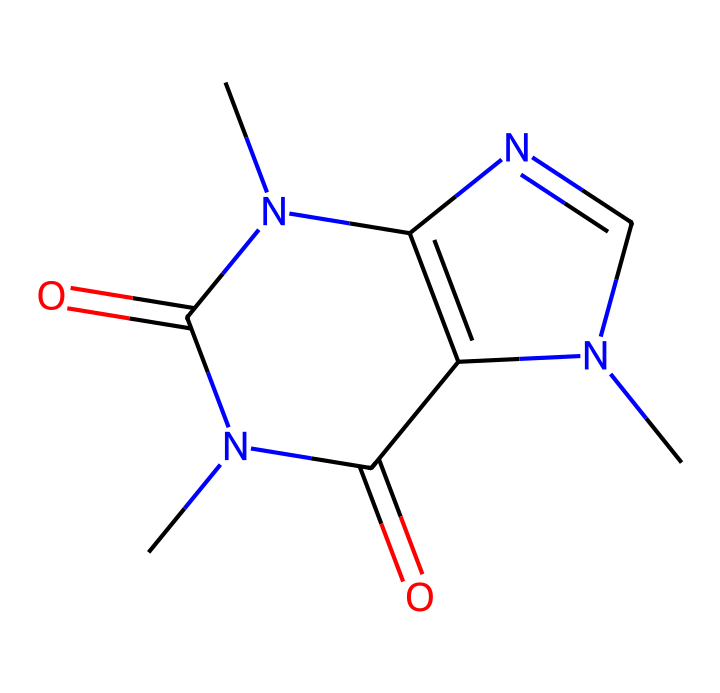What is the molecular formula of caffeine? By examining the chemical structure represented by the provided SMILES, we can identify the number of each type of atom present. In this case, we see that there are 8 carbon atoms, 10 hydrogen atoms, 4 nitrogen atoms, and 2 oxygen atoms. This allows us to determine the molecular formula, which is C8H10N4O2.
Answer: C8H10N4O2 How many nitrogen atoms are in the caffeine structure? Looking at the SMILES notation, we can directly count the nitrogen atoms. The 'N' symbols indicate the presence of nitrogen within the molecule. In the case of caffeine, there are 4 nitrogen atoms present.
Answer: 4 What type of chemical is caffeine classified as? Caffeine must be classified by its structure and properties. As it contains nitrogen and exhibits basic properties common to nitrogen-based compounds, caffeine is classified as an alkaloid.
Answer: alkaloid What type of bonding is present in caffeine? The molecule consists mainly of covalent bonds, which are formed between carbon, hydrogen, nitrogen, and oxygen atoms. Covalent bonds involve the sharing of electrons between atoms. This structural organization indicates that caffeine has a predominately covalent nature.
Answer: covalent What does the presence of nitrogen in caffeine contribute to its behavior? Nitrogen atoms in alkaloids like caffeine significantly contribute to their pharmacological effects. The nitrogen can engage in hydrogen bonding and influence solubility and interaction with biological receptors, hence affecting caffeine's stimulant properties.
Answer: pharmacological effects 